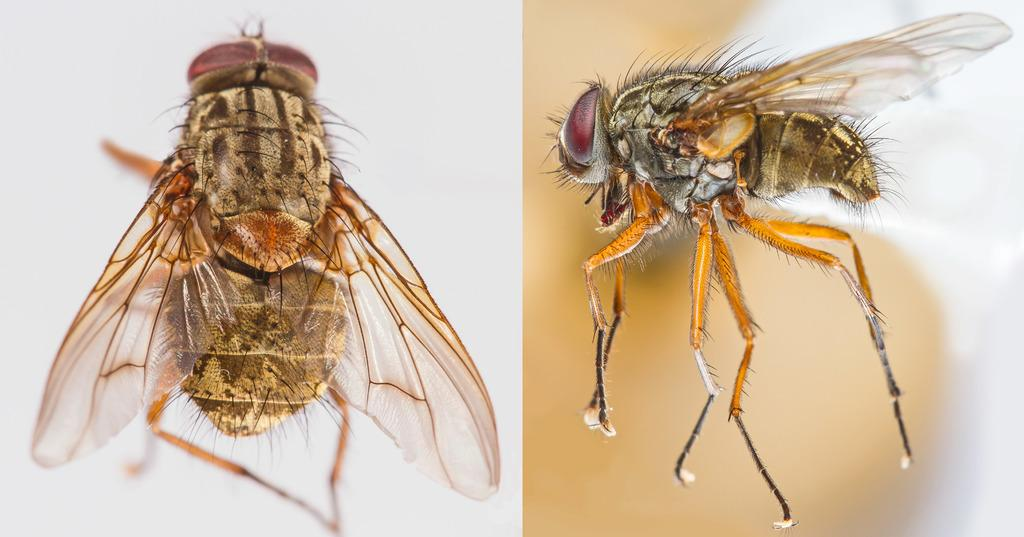How many images are included in the collage? The collage includes two images. What is a common element in both images? There is a fly in each of the two images. What type of marble is used as a background in the image? There is no marble present in the image; it is a collage with two images, each featuring a fly. 